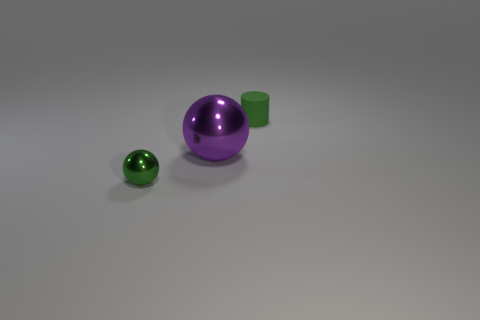The other tiny object that is the same color as the tiny rubber object is what shape? The tiny object that shares the same glossy green color as the tiny rubber-like cylinder is spherical in shape, similar to a small marble or bead. 